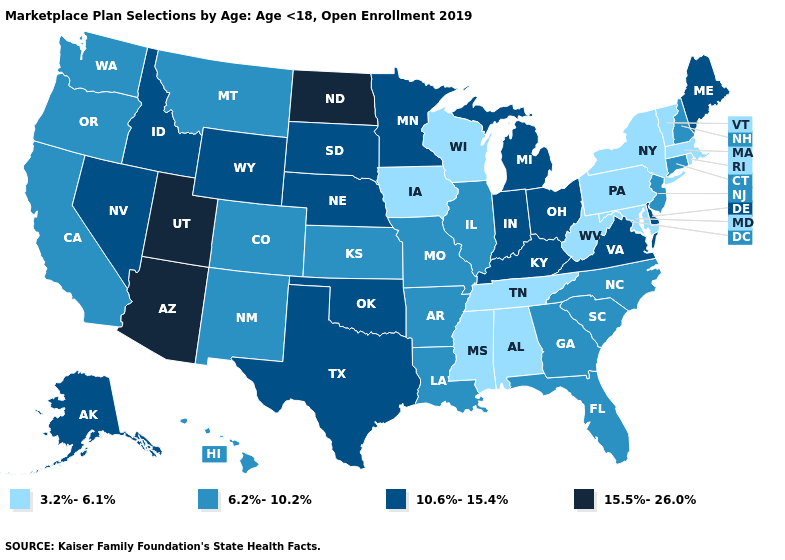What is the value of Montana?
Quick response, please. 6.2%-10.2%. Does Alabama have the same value as Iowa?
Write a very short answer. Yes. Name the states that have a value in the range 15.5%-26.0%?
Concise answer only. Arizona, North Dakota, Utah. Does Nebraska have the lowest value in the USA?
Keep it brief. No. What is the lowest value in the South?
Be succinct. 3.2%-6.1%. Does Oregon have the lowest value in the West?
Quick response, please. Yes. What is the value of Alaska?
Concise answer only. 10.6%-15.4%. What is the lowest value in the South?
Quick response, please. 3.2%-6.1%. Does New York have the lowest value in the Northeast?
Write a very short answer. Yes. Is the legend a continuous bar?
Concise answer only. No. What is the value of New York?
Give a very brief answer. 3.2%-6.1%. Name the states that have a value in the range 6.2%-10.2%?
Give a very brief answer. Arkansas, California, Colorado, Connecticut, Florida, Georgia, Hawaii, Illinois, Kansas, Louisiana, Missouri, Montana, New Hampshire, New Jersey, New Mexico, North Carolina, Oregon, South Carolina, Washington. Name the states that have a value in the range 15.5%-26.0%?
Answer briefly. Arizona, North Dakota, Utah. What is the value of Utah?
Be succinct. 15.5%-26.0%. Among the states that border Delaware , which have the lowest value?
Keep it brief. Maryland, Pennsylvania. 